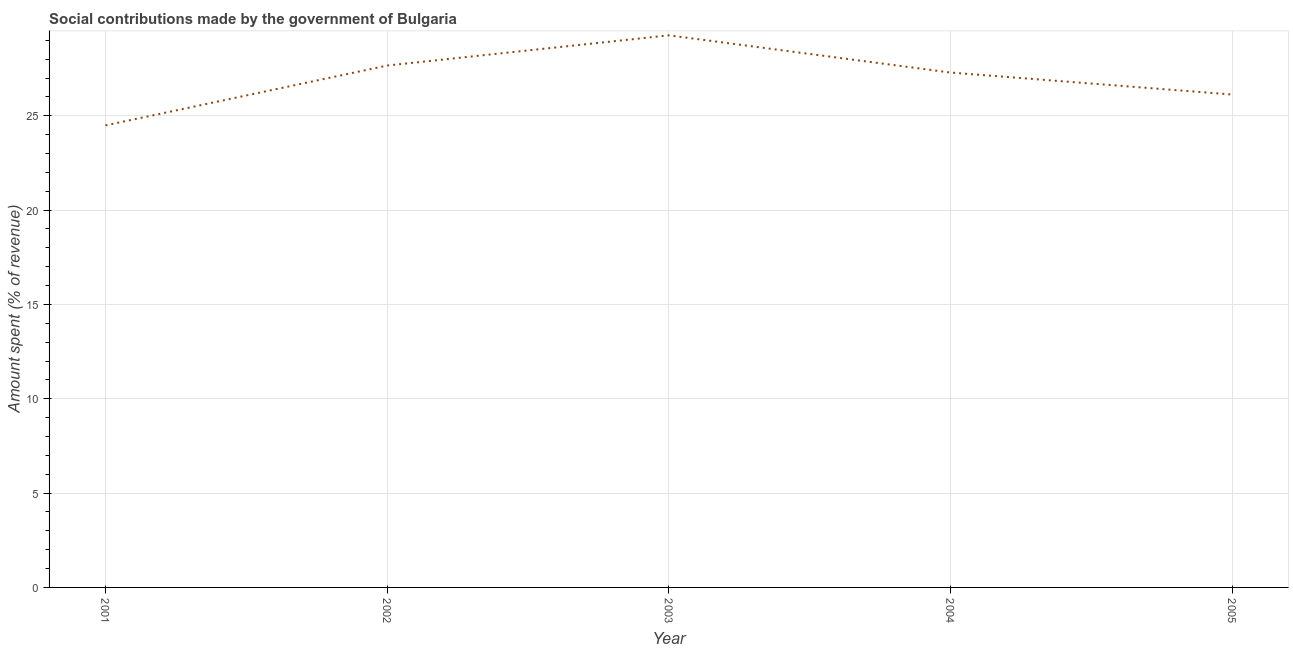What is the amount spent in making social contributions in 2005?
Make the answer very short. 26.13. Across all years, what is the maximum amount spent in making social contributions?
Provide a succinct answer. 29.27. Across all years, what is the minimum amount spent in making social contributions?
Provide a succinct answer. 24.49. What is the sum of the amount spent in making social contributions?
Ensure brevity in your answer.  134.84. What is the difference between the amount spent in making social contributions in 2004 and 2005?
Your answer should be compact. 1.16. What is the average amount spent in making social contributions per year?
Your answer should be compact. 26.97. What is the median amount spent in making social contributions?
Provide a short and direct response. 27.29. In how many years, is the amount spent in making social contributions greater than 12 %?
Your answer should be very brief. 5. What is the ratio of the amount spent in making social contributions in 2003 to that in 2004?
Your response must be concise. 1.07. What is the difference between the highest and the second highest amount spent in making social contributions?
Keep it short and to the point. 1.6. Is the sum of the amount spent in making social contributions in 2004 and 2005 greater than the maximum amount spent in making social contributions across all years?
Your response must be concise. Yes. What is the difference between the highest and the lowest amount spent in making social contributions?
Give a very brief answer. 4.77. Does the amount spent in making social contributions monotonically increase over the years?
Make the answer very short. No. How many years are there in the graph?
Offer a very short reply. 5. Are the values on the major ticks of Y-axis written in scientific E-notation?
Give a very brief answer. No. Does the graph contain any zero values?
Provide a succinct answer. No. Does the graph contain grids?
Provide a succinct answer. Yes. What is the title of the graph?
Ensure brevity in your answer.  Social contributions made by the government of Bulgaria. What is the label or title of the X-axis?
Offer a terse response. Year. What is the label or title of the Y-axis?
Give a very brief answer. Amount spent (% of revenue). What is the Amount spent (% of revenue) in 2001?
Provide a succinct answer. 24.49. What is the Amount spent (% of revenue) of 2002?
Ensure brevity in your answer.  27.66. What is the Amount spent (% of revenue) of 2003?
Your response must be concise. 29.27. What is the Amount spent (% of revenue) in 2004?
Offer a very short reply. 27.29. What is the Amount spent (% of revenue) of 2005?
Make the answer very short. 26.13. What is the difference between the Amount spent (% of revenue) in 2001 and 2002?
Provide a short and direct response. -3.17. What is the difference between the Amount spent (% of revenue) in 2001 and 2003?
Provide a succinct answer. -4.77. What is the difference between the Amount spent (% of revenue) in 2001 and 2004?
Provide a short and direct response. -2.8. What is the difference between the Amount spent (% of revenue) in 2001 and 2005?
Give a very brief answer. -1.64. What is the difference between the Amount spent (% of revenue) in 2002 and 2003?
Offer a very short reply. -1.6. What is the difference between the Amount spent (% of revenue) in 2002 and 2004?
Provide a short and direct response. 0.37. What is the difference between the Amount spent (% of revenue) in 2002 and 2005?
Your answer should be compact. 1.54. What is the difference between the Amount spent (% of revenue) in 2003 and 2004?
Keep it short and to the point. 1.97. What is the difference between the Amount spent (% of revenue) in 2003 and 2005?
Your answer should be compact. 3.14. What is the difference between the Amount spent (% of revenue) in 2004 and 2005?
Offer a terse response. 1.16. What is the ratio of the Amount spent (% of revenue) in 2001 to that in 2002?
Offer a very short reply. 0.89. What is the ratio of the Amount spent (% of revenue) in 2001 to that in 2003?
Your response must be concise. 0.84. What is the ratio of the Amount spent (% of revenue) in 2001 to that in 2004?
Your answer should be very brief. 0.9. What is the ratio of the Amount spent (% of revenue) in 2001 to that in 2005?
Keep it short and to the point. 0.94. What is the ratio of the Amount spent (% of revenue) in 2002 to that in 2003?
Your response must be concise. 0.94. What is the ratio of the Amount spent (% of revenue) in 2002 to that in 2005?
Your response must be concise. 1.06. What is the ratio of the Amount spent (% of revenue) in 2003 to that in 2004?
Make the answer very short. 1.07. What is the ratio of the Amount spent (% of revenue) in 2003 to that in 2005?
Offer a very short reply. 1.12. What is the ratio of the Amount spent (% of revenue) in 2004 to that in 2005?
Offer a terse response. 1.04. 